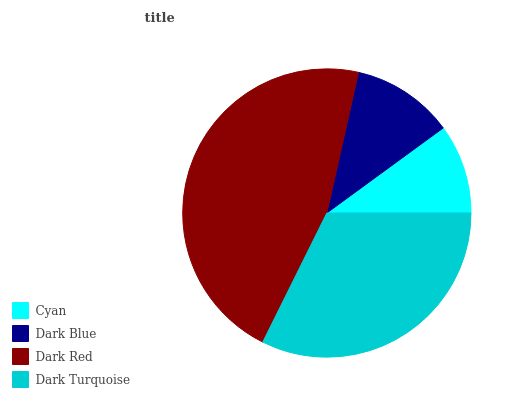Is Cyan the minimum?
Answer yes or no. Yes. Is Dark Red the maximum?
Answer yes or no. Yes. Is Dark Blue the minimum?
Answer yes or no. No. Is Dark Blue the maximum?
Answer yes or no. No. Is Dark Blue greater than Cyan?
Answer yes or no. Yes. Is Cyan less than Dark Blue?
Answer yes or no. Yes. Is Cyan greater than Dark Blue?
Answer yes or no. No. Is Dark Blue less than Cyan?
Answer yes or no. No. Is Dark Turquoise the high median?
Answer yes or no. Yes. Is Dark Blue the low median?
Answer yes or no. Yes. Is Dark Blue the high median?
Answer yes or no. No. Is Cyan the low median?
Answer yes or no. No. 